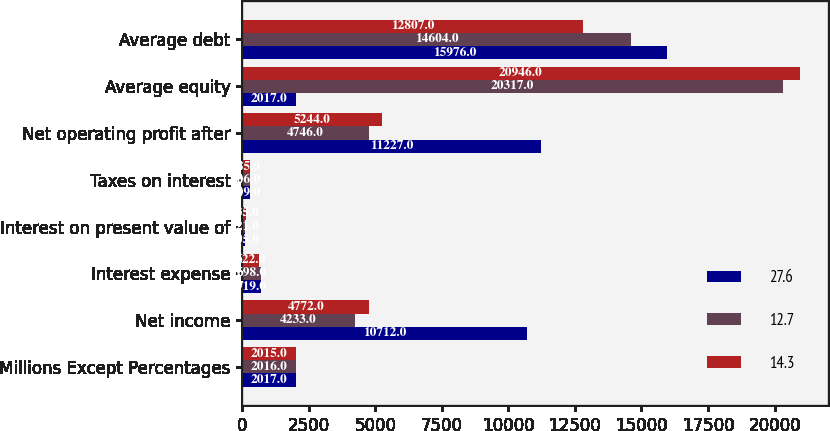Convert chart. <chart><loc_0><loc_0><loc_500><loc_500><stacked_bar_chart><ecel><fcel>Millions Except Percentages<fcel>Net income<fcel>Interest expense<fcel>Interest on present value of<fcel>Taxes on interest<fcel>Net operating profit after<fcel>Average equity<fcel>Average debt<nl><fcel>27.6<fcel>2017<fcel>10712<fcel>719<fcel>105<fcel>309<fcel>11227<fcel>2017<fcel>15976<nl><fcel>12.7<fcel>2016<fcel>4233<fcel>698<fcel>121<fcel>306<fcel>4746<fcel>20317<fcel>14604<nl><fcel>14.3<fcel>2015<fcel>4772<fcel>622<fcel>135<fcel>285<fcel>5244<fcel>20946<fcel>12807<nl></chart> 